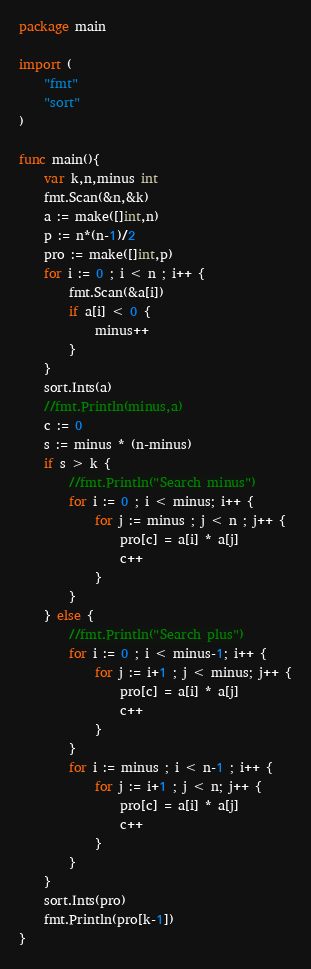<code> <loc_0><loc_0><loc_500><loc_500><_Go_>package main

import (
	"fmt"
	"sort"
)

func main(){
	var k,n,minus int
	fmt.Scan(&n,&k)
	a := make([]int,n)
	p := n*(n-1)/2
	pro := make([]int,p)
	for i := 0 ; i < n ; i++ {
		fmt.Scan(&a[i])
		if a[i] < 0 {
			minus++
		}
	}
	sort.Ints(a)
	//fmt.Println(minus,a)
	c := 0
	s := minus * (n-minus)
	if s > k {
		//fmt.Println("Search minus")
		for i := 0 ; i < minus; i++ {
			for j := minus ; j < n ; j++ {
				pro[c] = a[i] * a[j]
				c++
			}
		}
	} else {
		//fmt.Println("Search plus")
		for i := 0 ; i < minus-1; i++ {
			for j := i+1 ; j < minus; j++ {
				pro[c] = a[i] * a[j]
				c++
			}
		}
		for i := minus ; i < n-1 ; i++ {
			for j := i+1 ; j < n; j++ {
				pro[c] = a[i] * a[j]
				c++
			}
		}
	}
	sort.Ints(pro)
	fmt.Println(pro[k-1])
}
</code> 